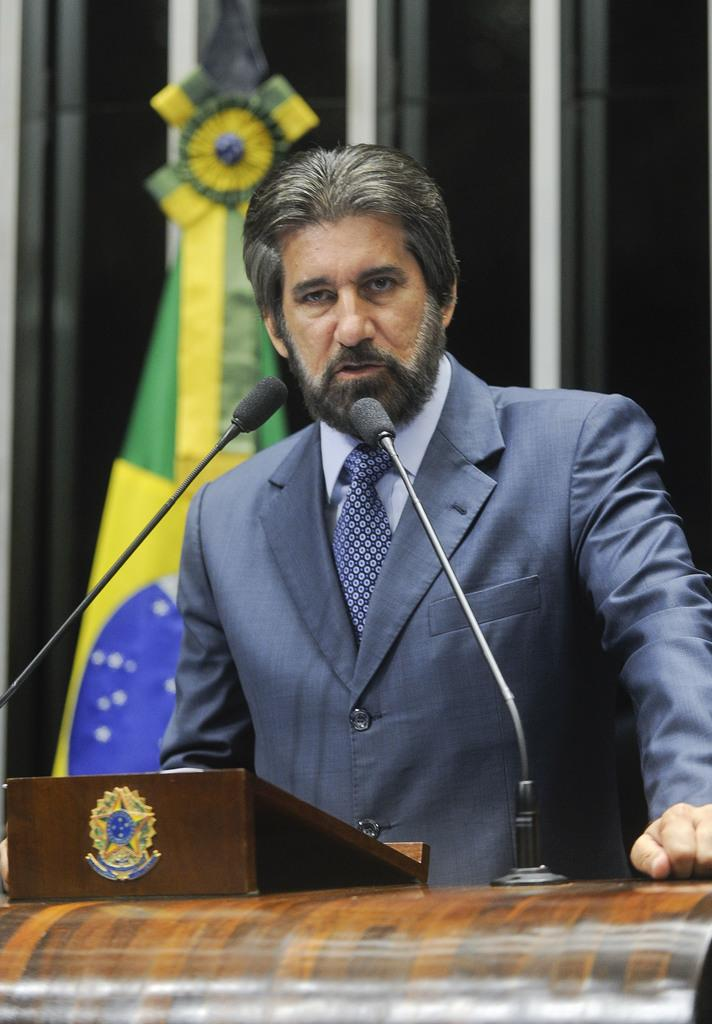What is the person in the image doing near the podium? There is a person standing near a podium in the image. What other objects or creatures are near the podium? There are mice near the podium in the image. What can be seen in the background of the image? There is a flag and rods in the background of the image. What color is the crayon being used by the person at the podium? There is no crayon present in the image; the person is not using any drawing or writing utensil. 